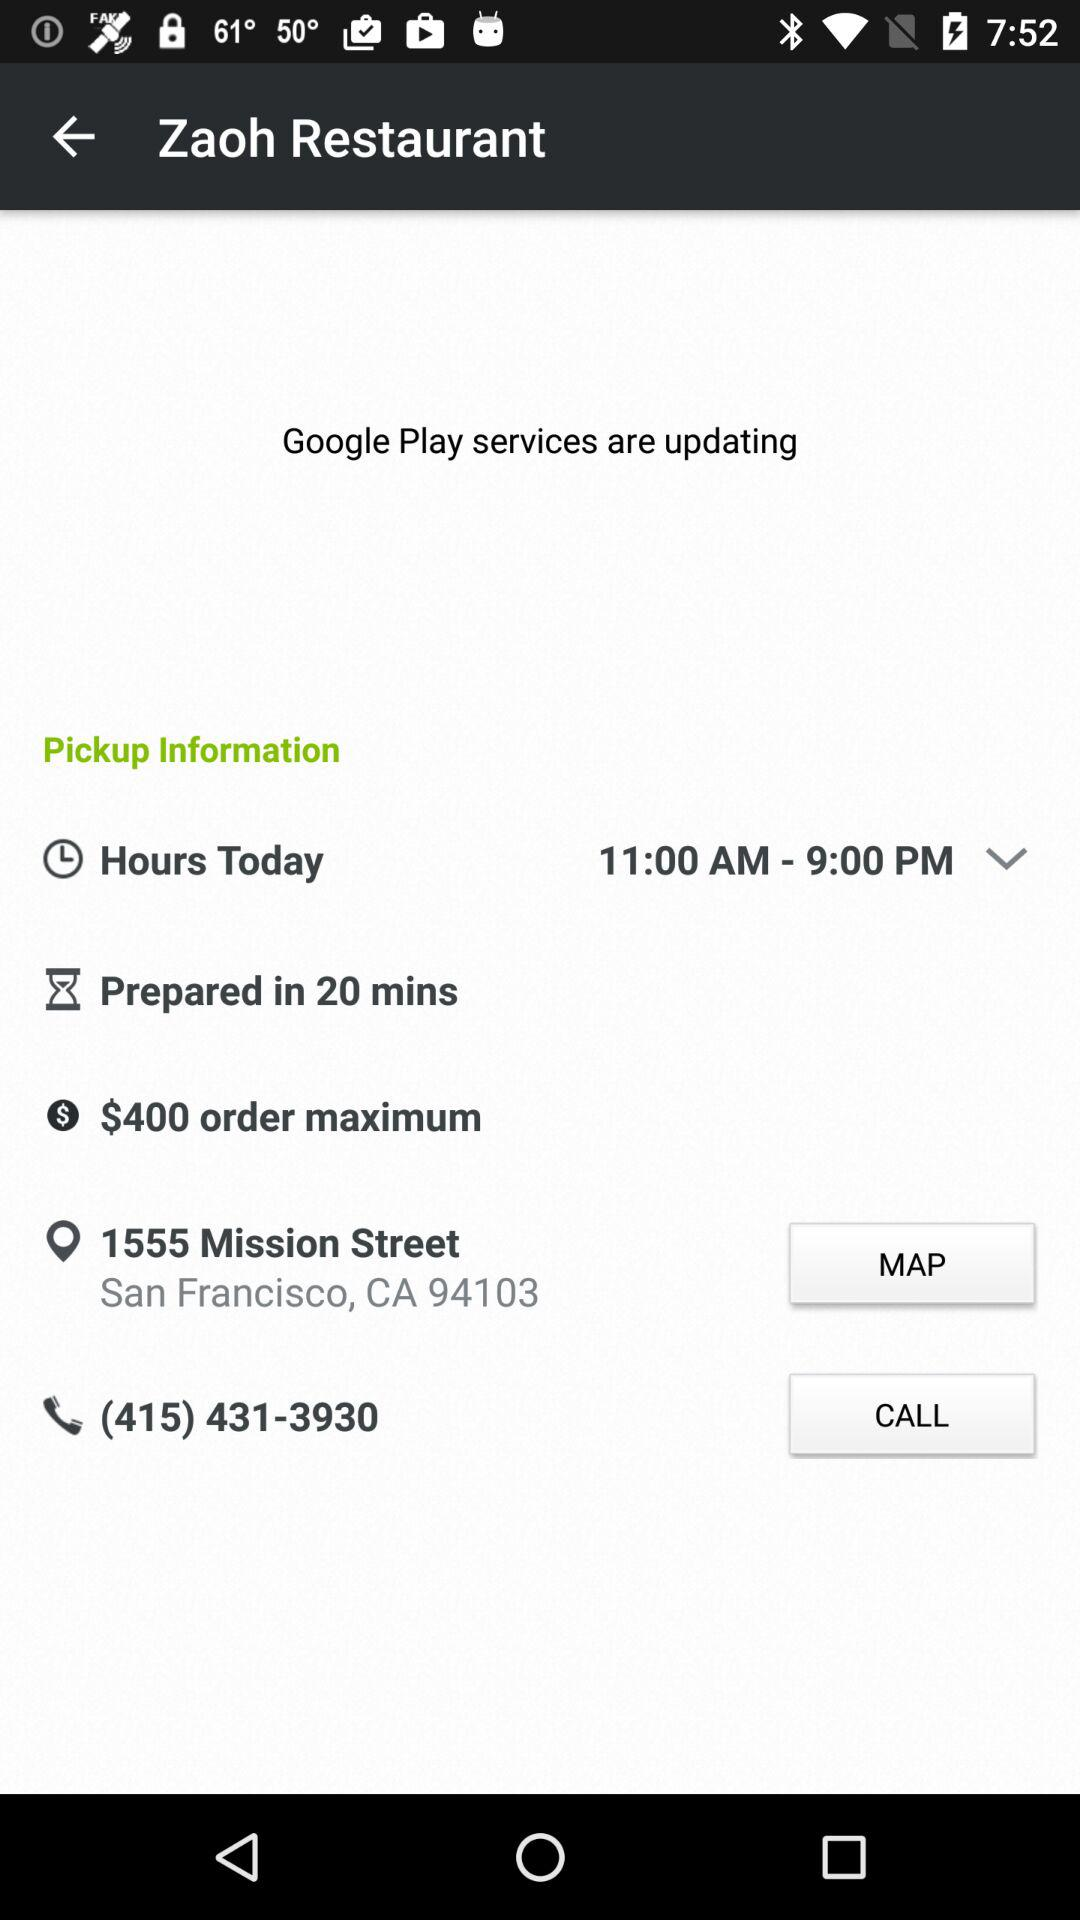What option is selected in "Hours Today"? In "Hours Today," the option "11:00 AM-9:00 PM" is selected. 